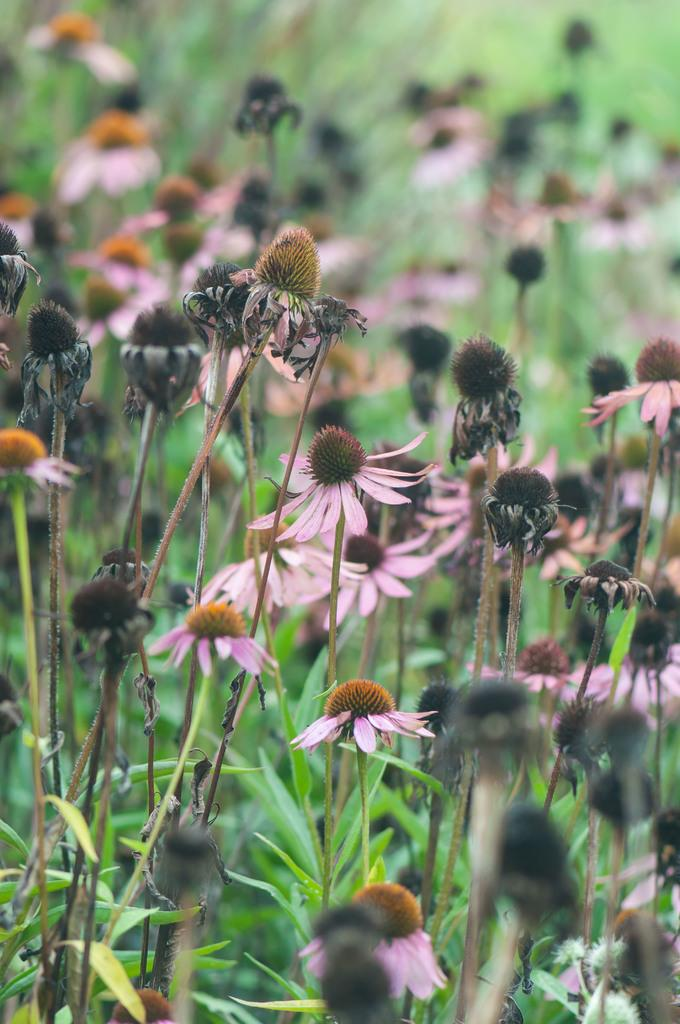What is the main subject of the image? The main subject of the image is a group of flowers. Where is the jail located in the image? There is no jail present in the image; it features a group of flowers. What type of rings can be seen on the flowers in the image? There are no rings present on the flowers in the image. 